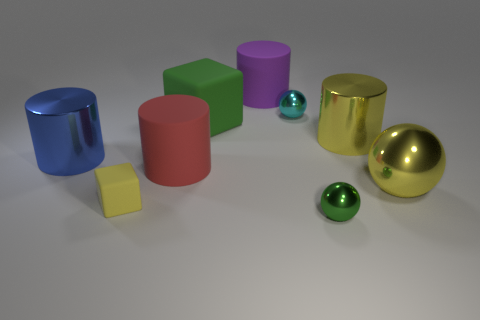There is a big shiny object that is to the left of the purple thing; is it the same shape as the large yellow shiny object in front of the big red matte cylinder?
Provide a succinct answer. No. There is a small ball that is behind the small yellow object in front of the rubber cylinder that is behind the large blue metallic object; what is it made of?
Provide a succinct answer. Metal. The blue shiny thing that is the same size as the green block is what shape?
Offer a very short reply. Cylinder. Are there any metal spheres that have the same color as the tiny matte cube?
Give a very brief answer. Yes. The yellow matte thing has what size?
Offer a very short reply. Small. Is the material of the big red object the same as the large yellow sphere?
Your answer should be very brief. No. What number of big purple matte cylinders are in front of the rubber block behind the metal cylinder to the left of the purple matte cylinder?
Your answer should be very brief. 0. What is the shape of the big matte object that is on the left side of the large green matte cube?
Provide a succinct answer. Cylinder. What number of other things are there of the same material as the yellow cube
Provide a succinct answer. 3. Do the large metal ball and the small block have the same color?
Ensure brevity in your answer.  Yes. 